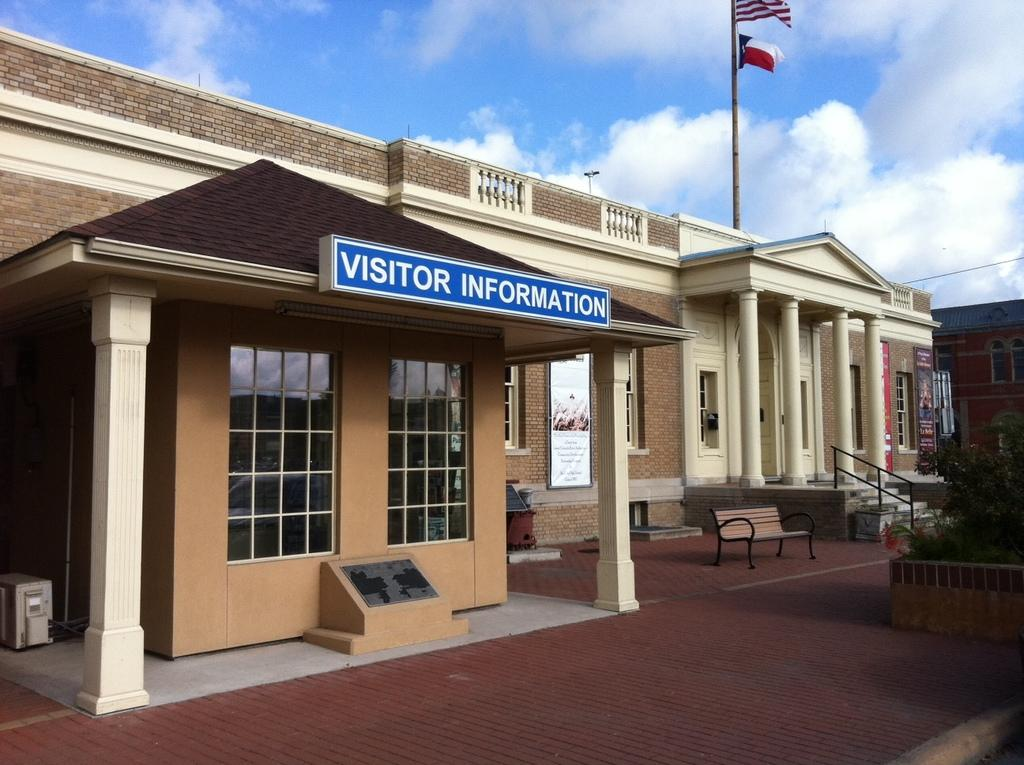What types of structures can be seen in the foreground of the image? There are architectures in the foreground of the image. What objects are present in the foreground of the image, besides the architectures? There is a board, a planter, a bench, and flags in the foreground of the image. What can be seen in the background of the image? The sky is visible in the background of the image. Can you see a rat eating lunch on the bench in the image? There is no rat or lunch present in the image; it only features architectures, a board, a planter, a bench, flags, and the sky. How many fingers are visible on the person holding the flag in the image? There are no people holding flags in the image, and therefore no fingers can be seen. 